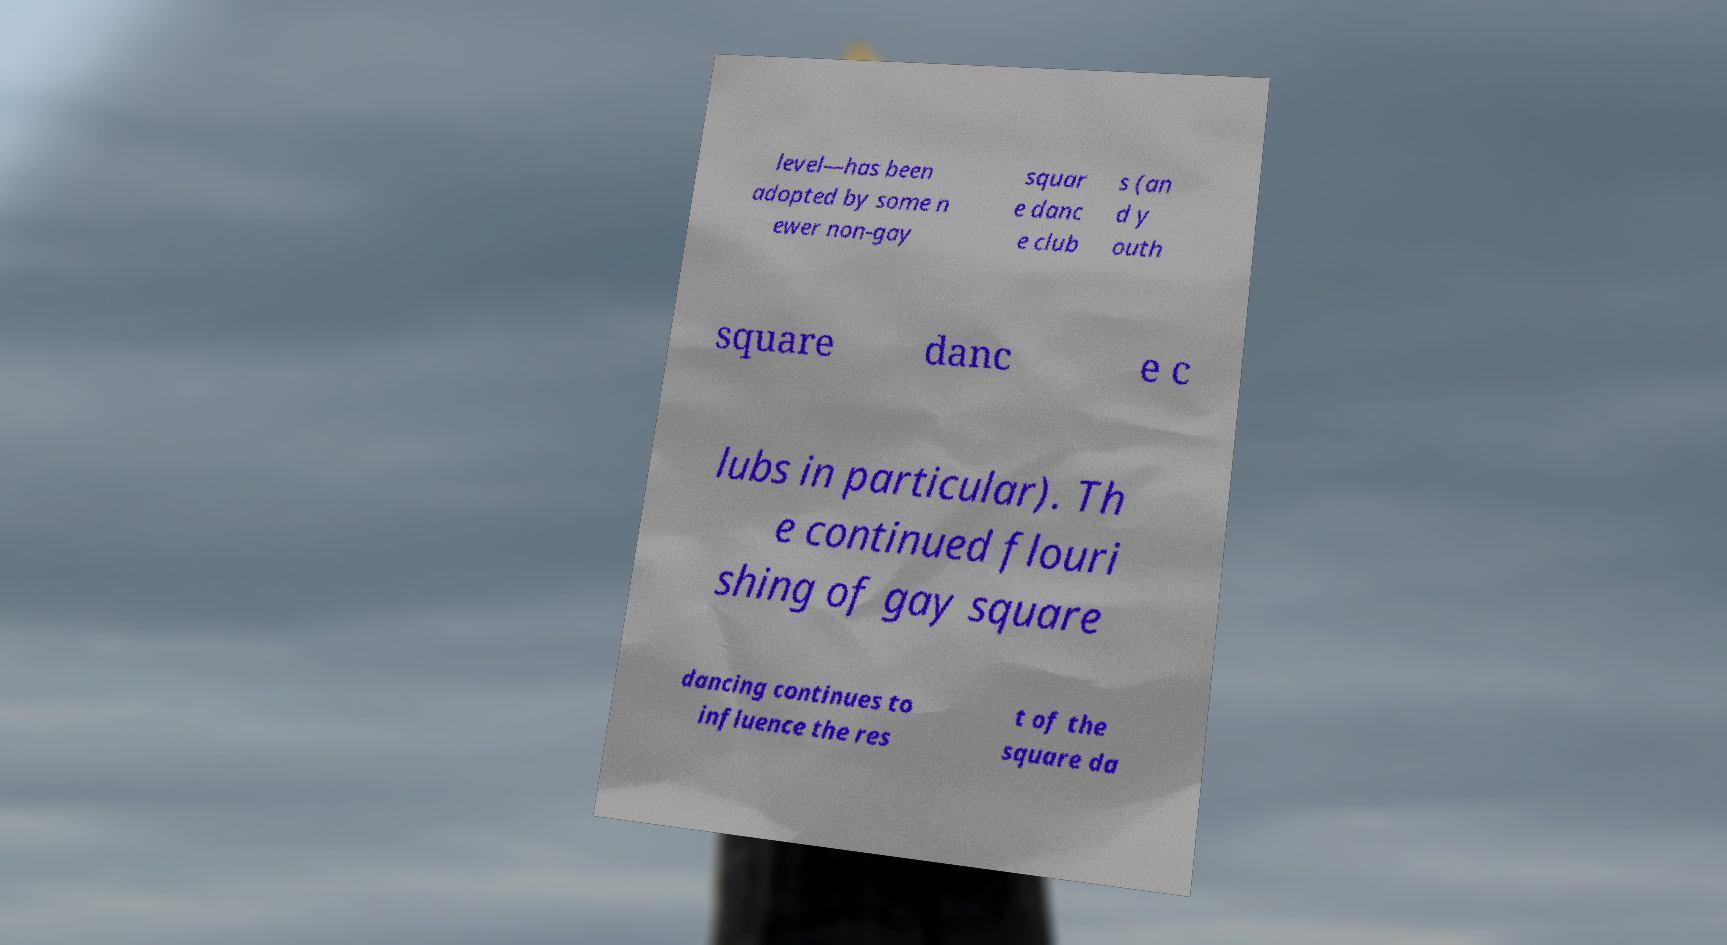Could you extract and type out the text from this image? level—has been adopted by some n ewer non-gay squar e danc e club s (an d y outh square danc e c lubs in particular). Th e continued flouri shing of gay square dancing continues to influence the res t of the square da 